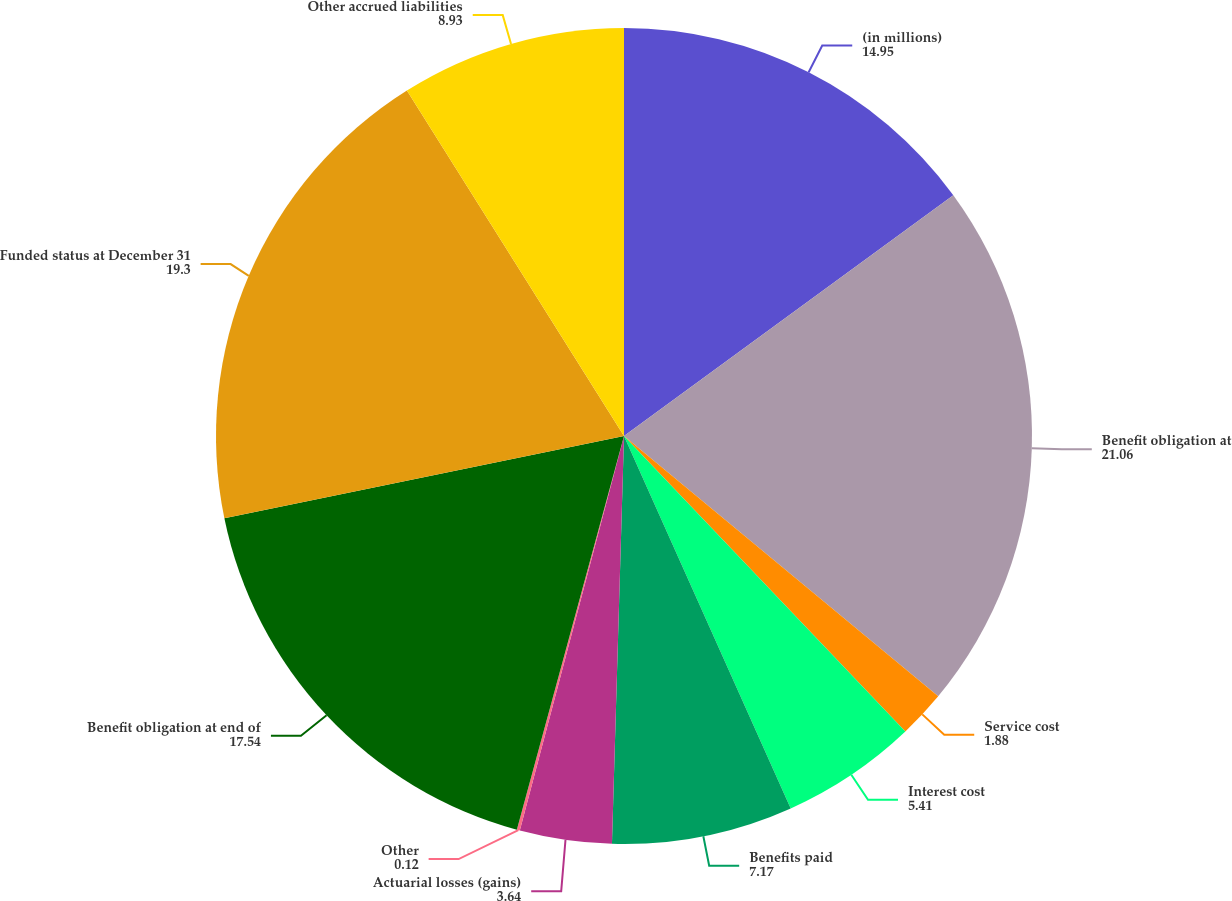<chart> <loc_0><loc_0><loc_500><loc_500><pie_chart><fcel>(in millions)<fcel>Benefit obligation at<fcel>Service cost<fcel>Interest cost<fcel>Benefits paid<fcel>Actuarial losses (gains)<fcel>Other<fcel>Benefit obligation at end of<fcel>Funded status at December 31<fcel>Other accrued liabilities<nl><fcel>14.95%<fcel>21.06%<fcel>1.88%<fcel>5.41%<fcel>7.17%<fcel>3.64%<fcel>0.12%<fcel>17.54%<fcel>19.3%<fcel>8.93%<nl></chart> 